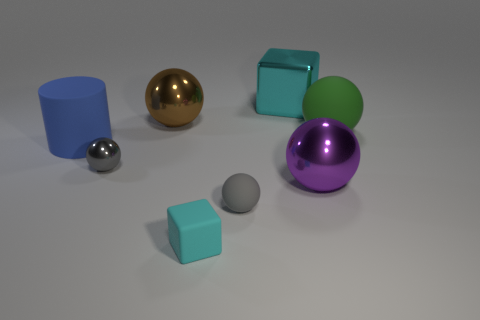What is the size of the metallic object that is the same color as the matte block?
Your response must be concise. Large. How many things are either cyan metallic objects or tiny metallic spheres?
Give a very brief answer. 2. There is a large shiny thing that is on the right side of the rubber cube and left of the purple sphere; what is its shape?
Make the answer very short. Cube. Do the green object and the cyan thing in front of the brown ball have the same shape?
Your answer should be compact. No. Are there any tiny cyan matte objects in front of the small gray metallic thing?
Your answer should be very brief. Yes. What material is the other sphere that is the same color as the tiny matte ball?
Provide a succinct answer. Metal. What number of spheres are blue matte things or cyan metallic things?
Ensure brevity in your answer.  0. Does the purple thing have the same shape as the small gray rubber object?
Ensure brevity in your answer.  Yes. What size is the matte sphere behind the gray shiny thing?
Your answer should be compact. Large. Is there another big block of the same color as the matte cube?
Your answer should be very brief. Yes. 